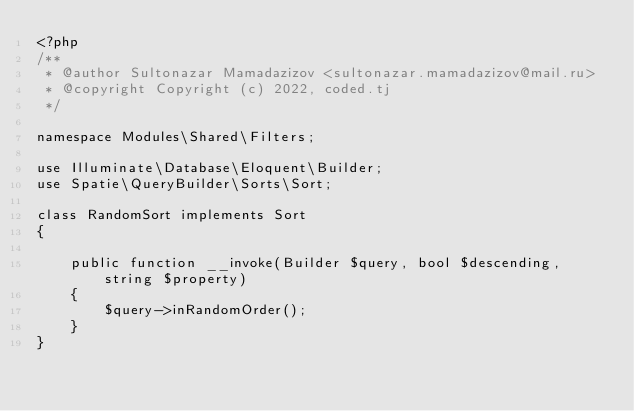<code> <loc_0><loc_0><loc_500><loc_500><_PHP_><?php
/**
 * @author Sultonazar Mamadazizov <sultonazar.mamadazizov@mail.ru>
 * @copyright Copyright (c) 2022, coded.tj
 */

namespace Modules\Shared\Filters;

use Illuminate\Database\Eloquent\Builder;
use Spatie\QueryBuilder\Sorts\Sort;

class RandomSort implements Sort
{

    public function __invoke(Builder $query, bool $descending, string $property)
    {
        $query->inRandomOrder();
    }
}
</code> 